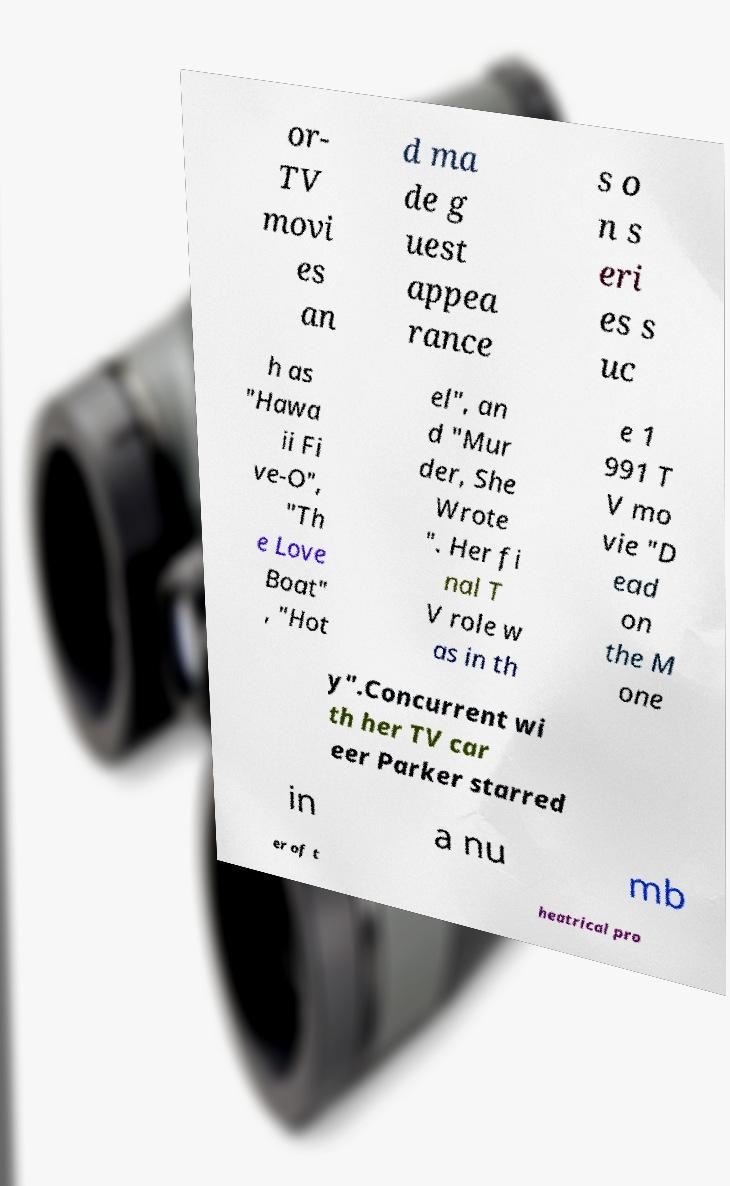Could you assist in decoding the text presented in this image and type it out clearly? or- TV movi es an d ma de g uest appea rance s o n s eri es s uc h as "Hawa ii Fi ve-O", "Th e Love Boat" , "Hot el", an d "Mur der, She Wrote ". Her fi nal T V role w as in th e 1 991 T V mo vie "D ead on the M one y".Concurrent wi th her TV car eer Parker starred in a nu mb er of t heatrical pro 